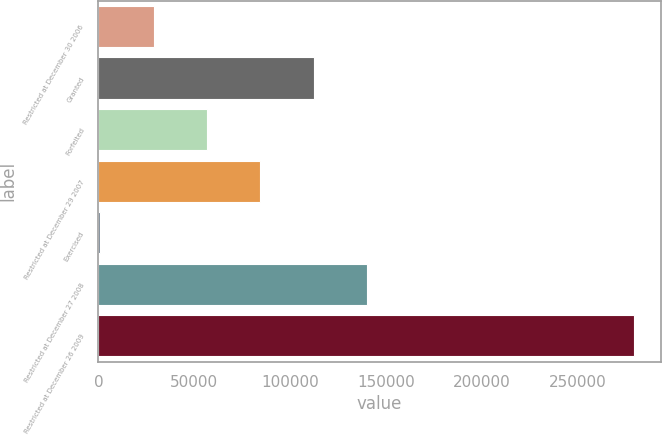<chart> <loc_0><loc_0><loc_500><loc_500><bar_chart><fcel>Restricted at December 30 2006<fcel>Granted<fcel>Forfeited<fcel>Restricted at December 29 2007<fcel>Exercised<fcel>Restricted at December 27 2008<fcel>Restricted at December 26 2009<nl><fcel>28848.2<fcel>112363<fcel>56686.4<fcel>84524.6<fcel>1010<fcel>140201<fcel>279392<nl></chart> 